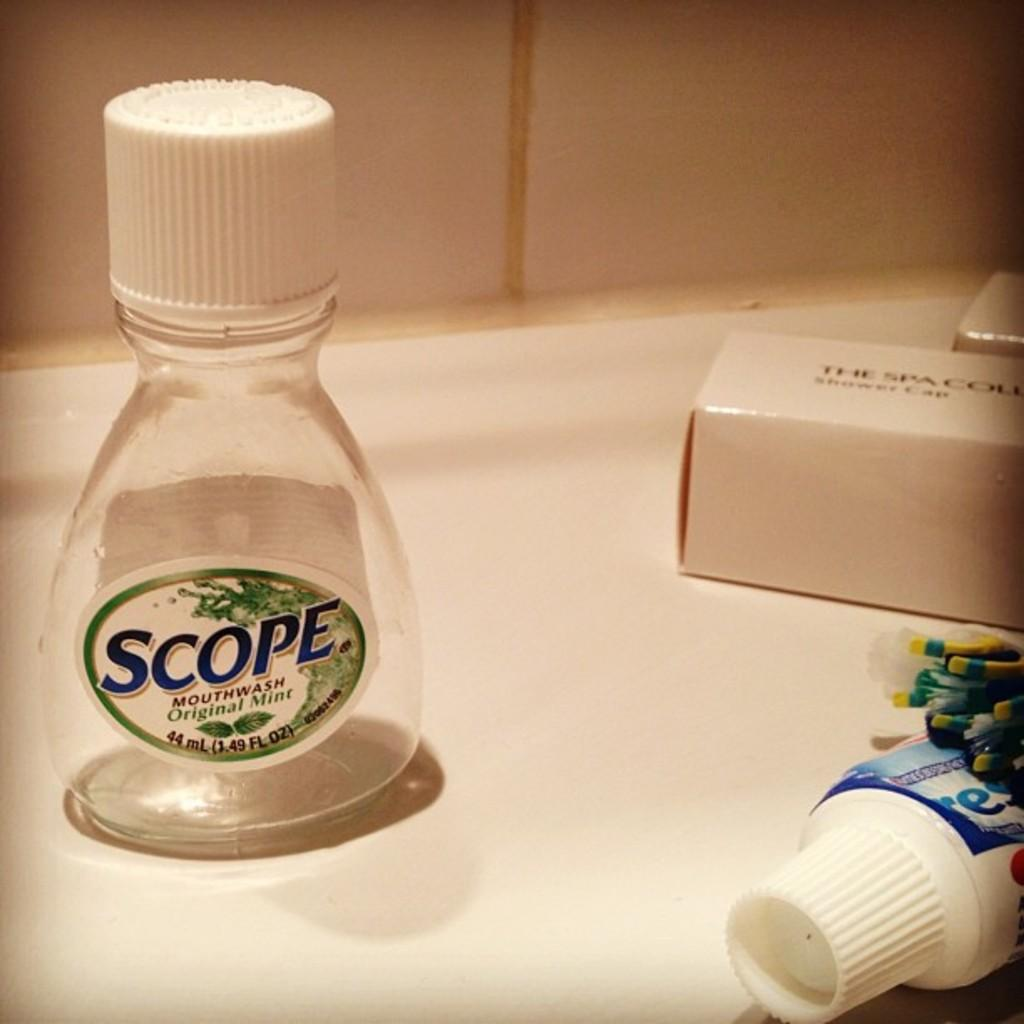<image>
Write a terse but informative summary of the picture. The plastic bottle has the brand name scope on it 